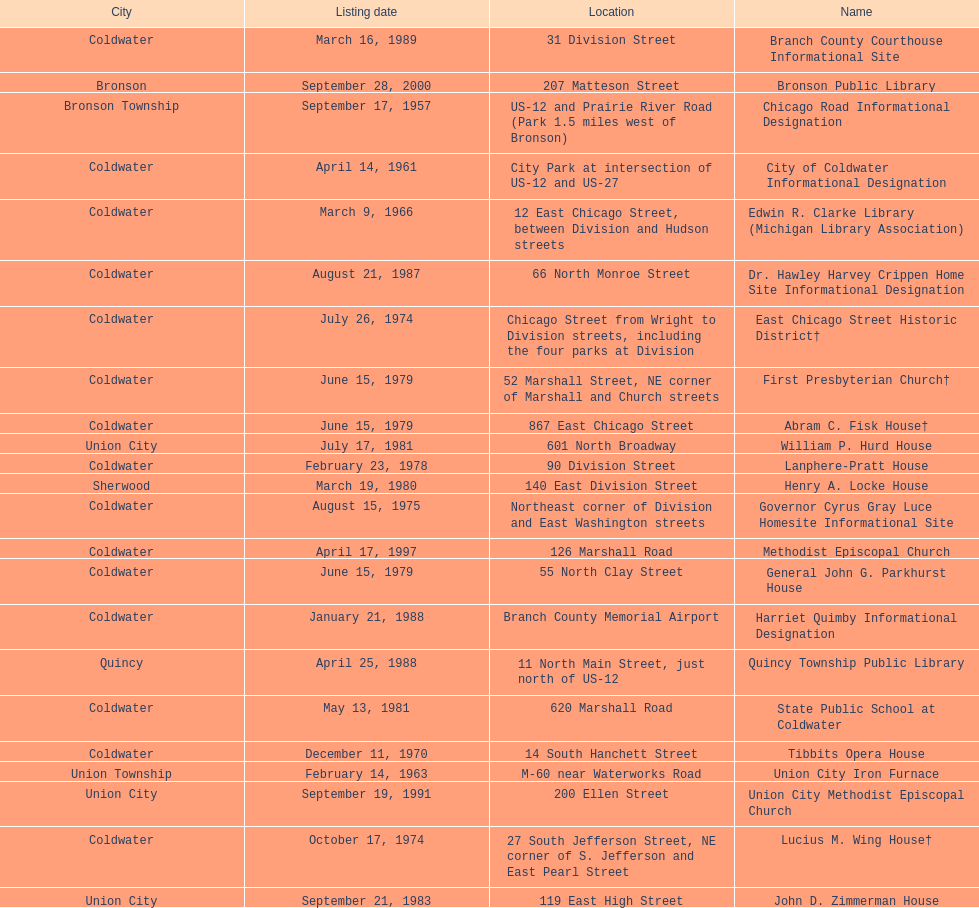How many sites were listed as historical before 1980? 12. 